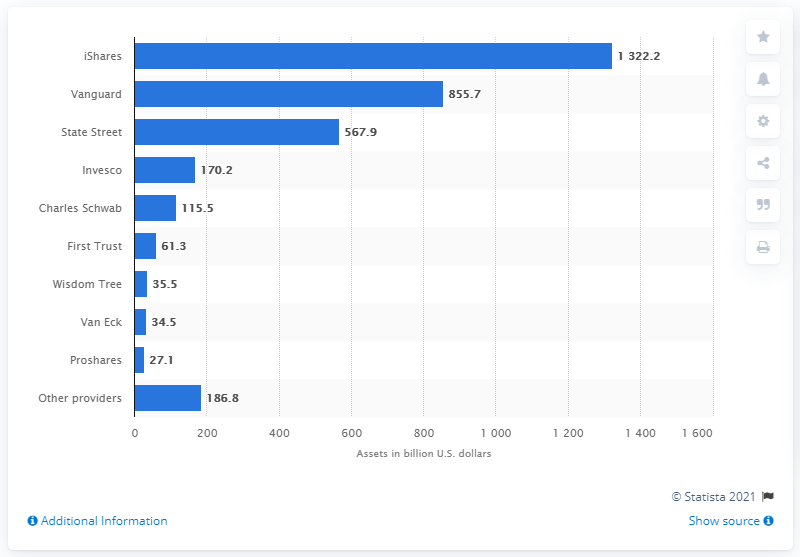Give some essential details in this illustration. State Street is the third largest exchange-traded product (ETP) provider worldwide. State Street had 567.9 billion dollars in managed exchange-traded product (ETP) assets as of December 31, 2018. 